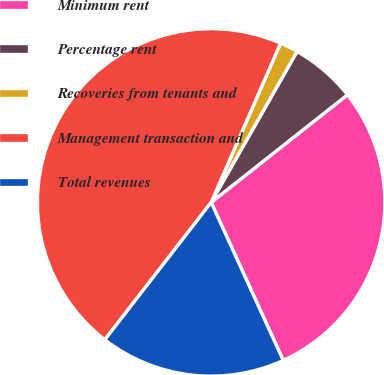<chart> <loc_0><loc_0><loc_500><loc_500><pie_chart><fcel>Minimum rent<fcel>Percentage rent<fcel>Recoveries from tenants and<fcel>Management transaction and<fcel>Total revenues<nl><fcel>28.82%<fcel>6.13%<fcel>1.69%<fcel>46.06%<fcel>17.3%<nl></chart> 